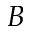<formula> <loc_0><loc_0><loc_500><loc_500>B</formula> 